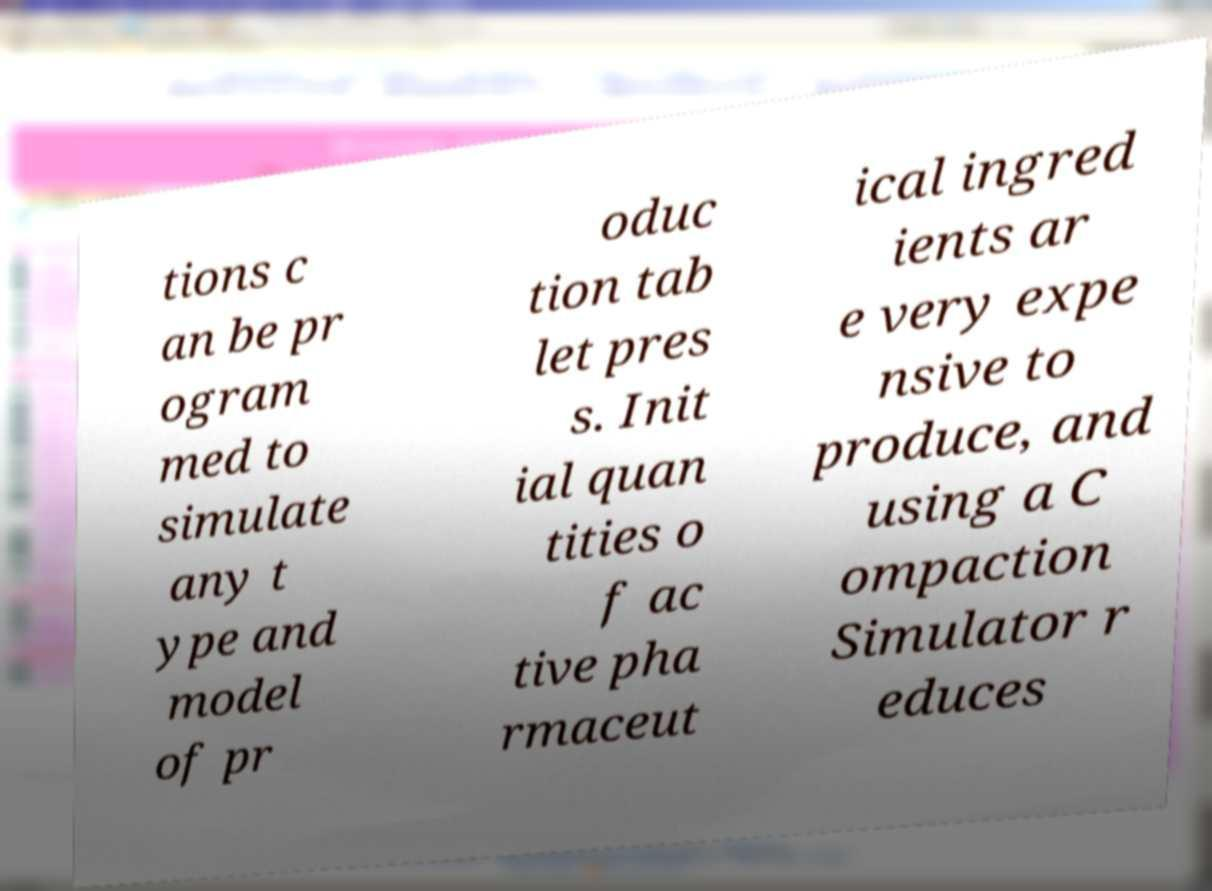Please read and relay the text visible in this image. What does it say? tions c an be pr ogram med to simulate any t ype and model of pr oduc tion tab let pres s. Init ial quan tities o f ac tive pha rmaceut ical ingred ients ar e very expe nsive to produce, and using a C ompaction Simulator r educes 